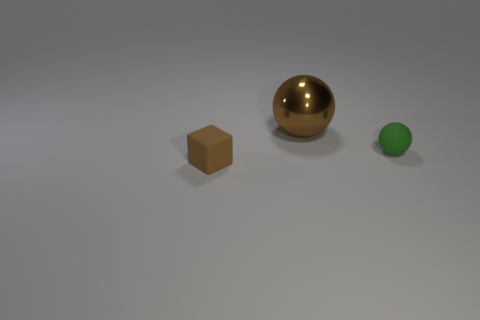What number of tiny objects have the same material as the green sphere?
Offer a very short reply. 1. Does the small thing on the right side of the large brown shiny sphere have the same shape as the large object?
Your answer should be compact. Yes. There is a thing on the left side of the large brown metallic ball; what shape is it?
Keep it short and to the point. Cube. There is a thing that is the same color as the small cube; what size is it?
Your response must be concise. Large. What material is the green ball?
Ensure brevity in your answer.  Rubber. There is a thing that is the same size as the rubber cube; what color is it?
Your response must be concise. Green. What shape is the object that is the same color as the shiny ball?
Offer a very short reply. Cube. Do the small green object and the large object have the same shape?
Your response must be concise. Yes. There is a thing that is both in front of the large brown sphere and behind the tiny brown rubber thing; what is its material?
Provide a succinct answer. Rubber. How big is the brown sphere?
Ensure brevity in your answer.  Large. 